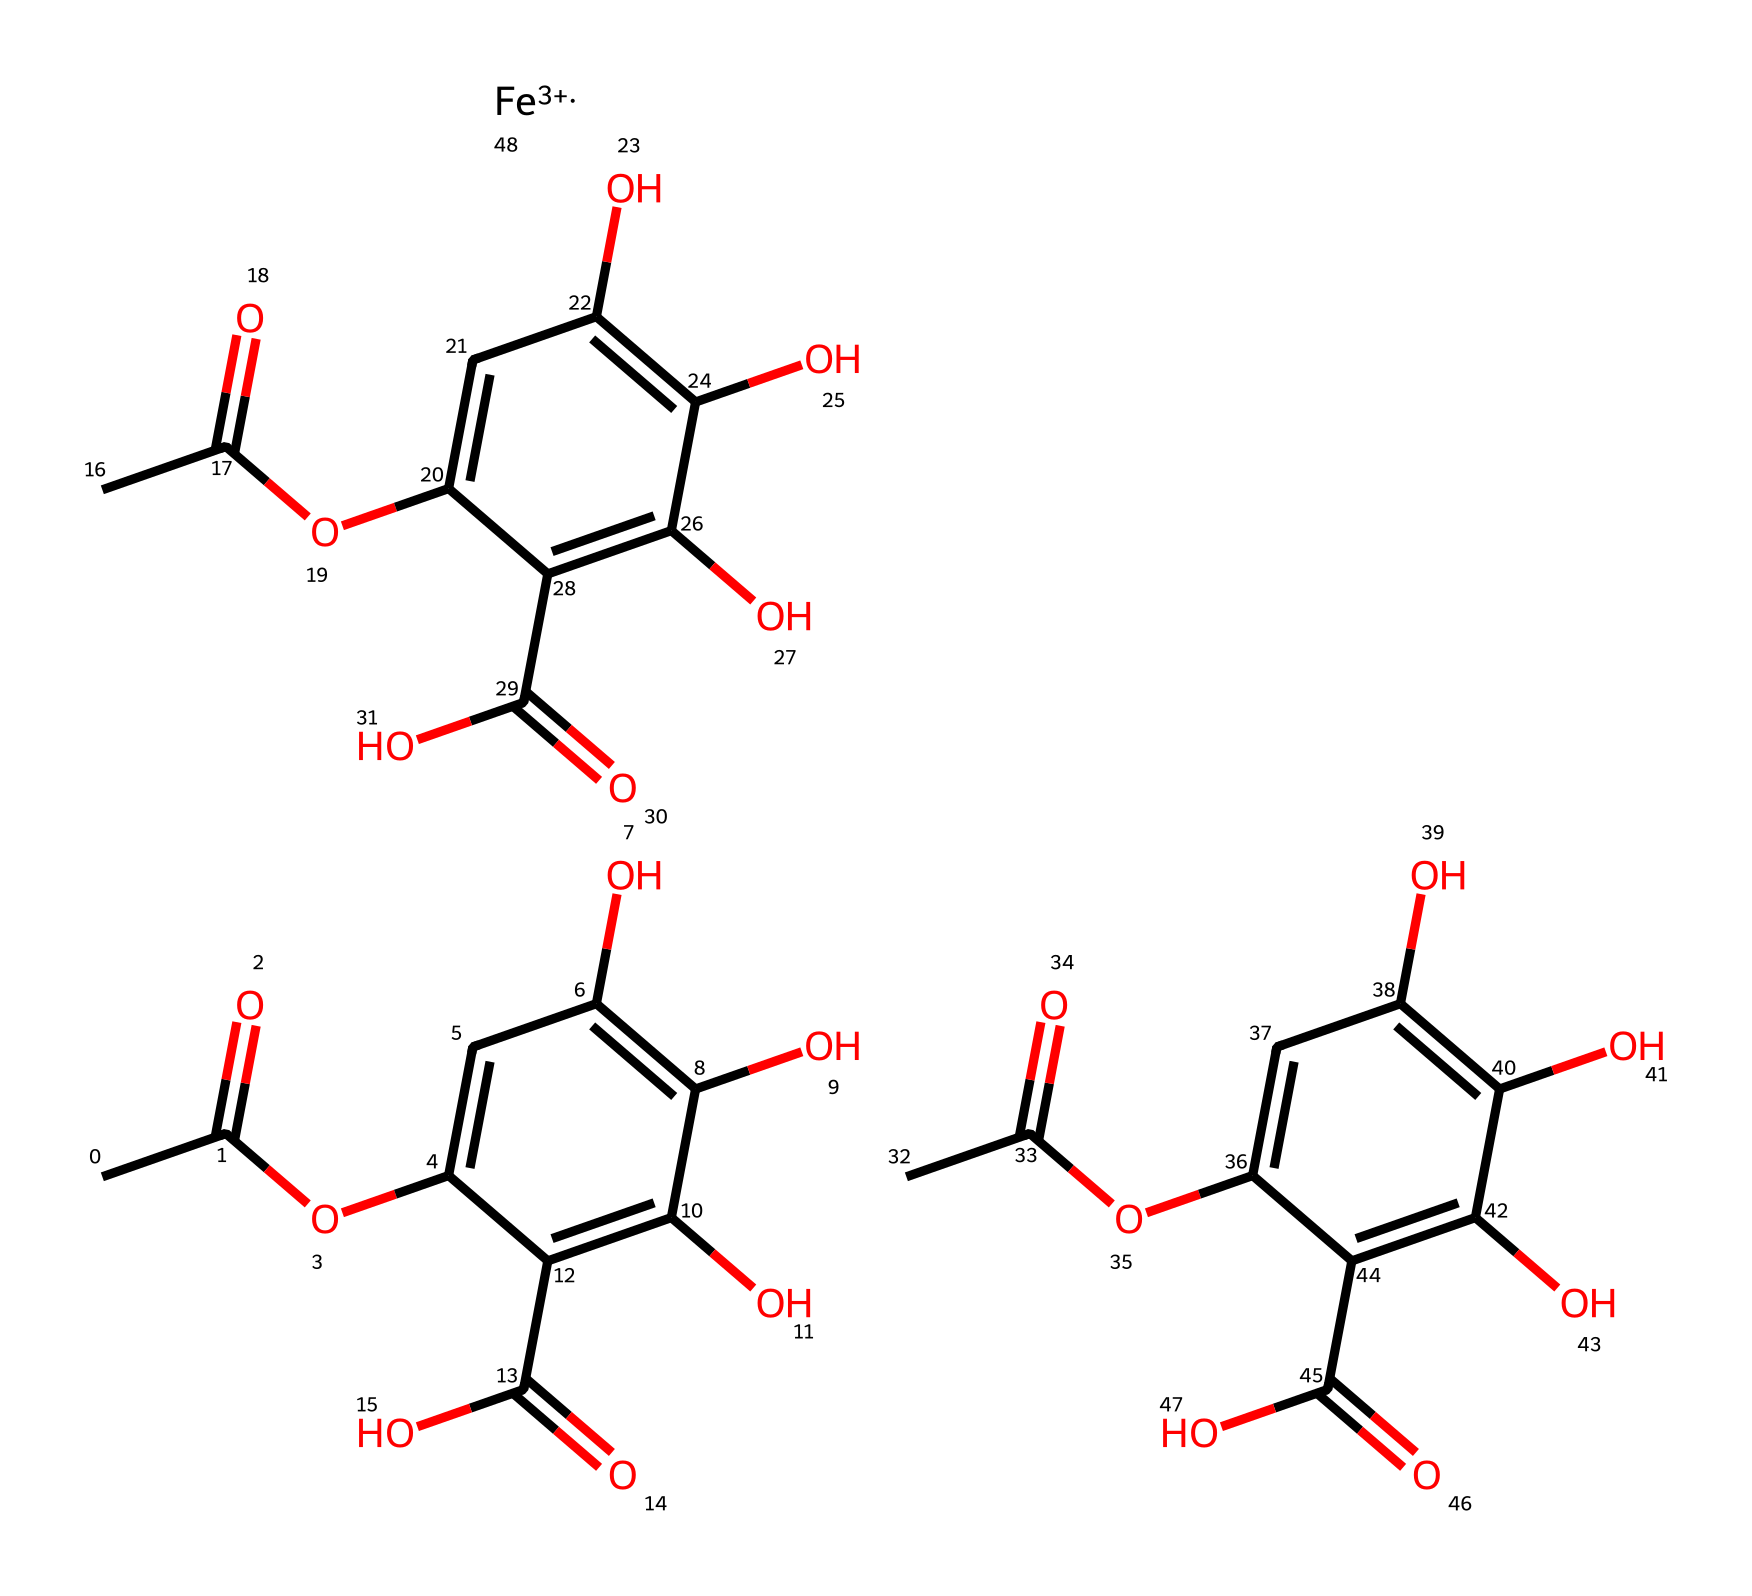What is the main functional group present in this chemical? The chemical structure shows multiple hydroxyl (-OH) groups attached to aromatic rings, indicating the presence of phenolic compounds. Additionally, the acetyl ester and carboxylic acid groups further support this functional analysis.
Answer: hydroxyl How many carbon atoms are present in the molecule? Analyzing the SMILES representation, you can count the 'C' symbols in the structure. There are 15 carbon atoms in total from three identical phenolic units and their respective functional groups.
Answer: 15 What type of bonding is present between the carbon atoms in the ring structure? The representation indicates that the carbon atoms in the aromatic ring are connected by alternating single and double bonds, characteristic of aromatic compounds, which provide stability through resonance.
Answer: resonance What metal ion is included in the ink composition? The SMILES notation explicitly denotes '[Fe+3]', indicating the presence of a ferric ion (Fe) in the composition.
Answer: Iron Which functional groups are responsible for the acidity of the ink? The chemical features carboxylic acid groups (-COOH) in addition to hydroxyl groups, both of which can donate protons (H+) leading to acidity in aqueous solutions.
Answer: carboxylic acid What type of organic compounds does this ink primarily consist of? The presence of phenolic compounds with functional groups such as hydroxyl and carboxylic acids suggests that the ink mainly consists of polyphenols, commonly found in natural inks.
Answer: polyphenols 